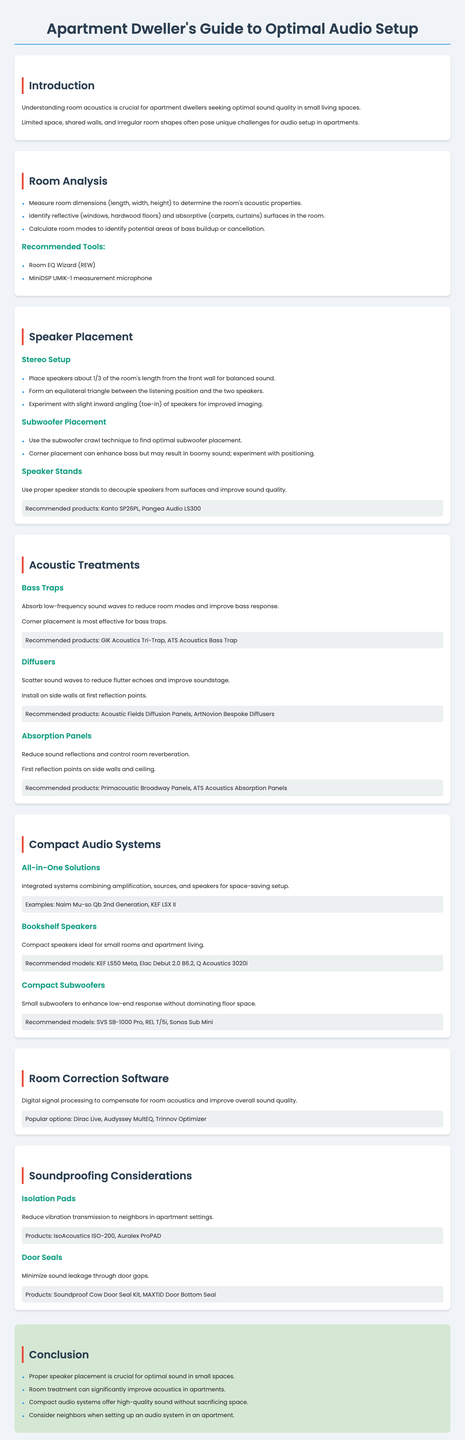what is the purpose of acoustic treatments? The purpose of acoustic treatments is to absorb low-frequency sound waves, reduce sound reflections, and control room reverberation.
Answer: Absorb low-frequency sound waves, reduce sound reflections, control room reverberation what is the recommended placement for speakers in a stereo setup? Speakers should be placed about 1/3 of the room's length from the front wall for balanced sound.
Answer: 1/3 of the room's length from the front wall which tool is recommended for measuring room acoustics? Room EQ Wizard (REW) is a recommended tool for measuring room acoustics.
Answer: Room EQ Wizard (REW) what are the recommended models for compact subwoofers? The document lists SVS SB-1000 Pro, REL T/5i, and Sonos Sub Mini as recommended models for compact subwoofers.
Answer: SVS SB-1000 Pro, REL T/5i, Sonos Sub Mini what is the key takeaway about room treatment? One key takeaway is that room treatment can significantly improve acoustics in apartments.
Answer: Room treatment can significantly improve acoustics which acoustic treatment product is most effective for bass traps? The GIK Acoustics Tri-Trap is recommended for effective bass traps.
Answer: GIK Acoustics Tri-Trap how should isolation pads be utilized in an apartment setting? Isolation pads are used to reduce vibration transmission to neighbors in apartment settings.
Answer: Reduce vibration transmission what does the document recommend for first reflection points? The document recommends installing absorption panels at first reflection points on side walls and ceiling.
Answer: Install absorption panels at first reflection points what does toe-in refer to in speaker placement? Toe-in refers to the slight inward angling of speakers for improved imaging.
Answer: Slight inward angling of speakers 